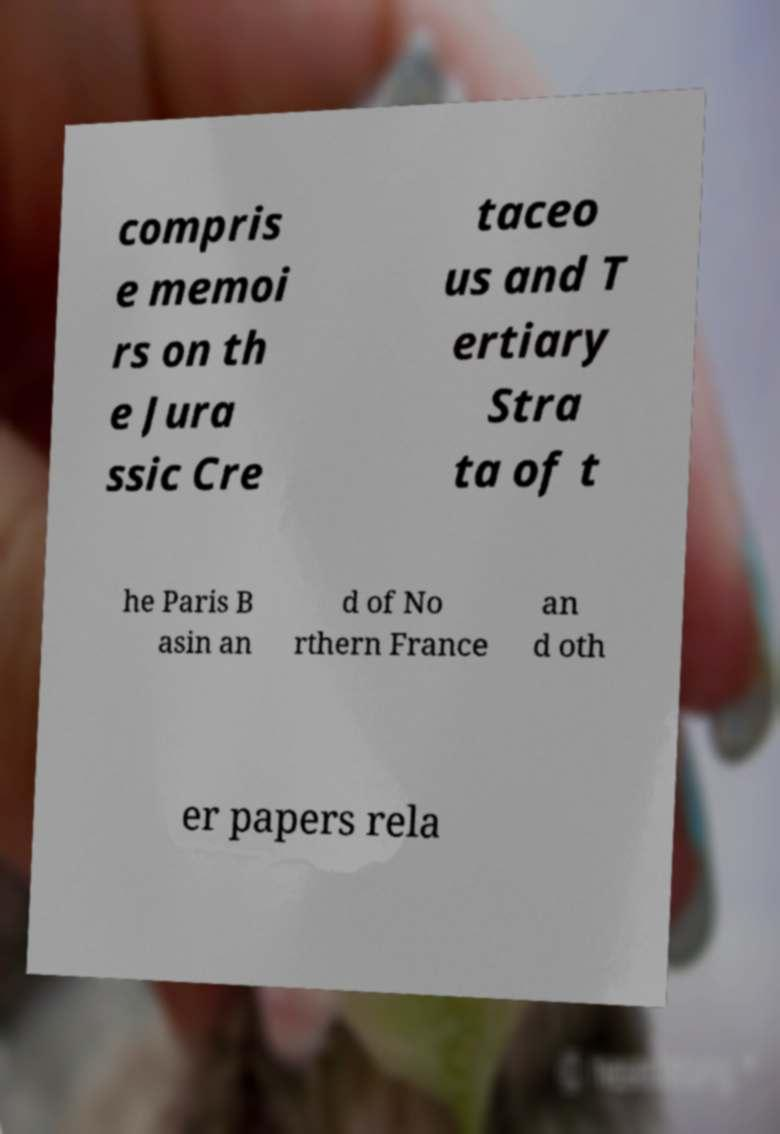Can you read and provide the text displayed in the image?This photo seems to have some interesting text. Can you extract and type it out for me? compris e memoi rs on th e Jura ssic Cre taceo us and T ertiary Stra ta of t he Paris B asin an d of No rthern France an d oth er papers rela 